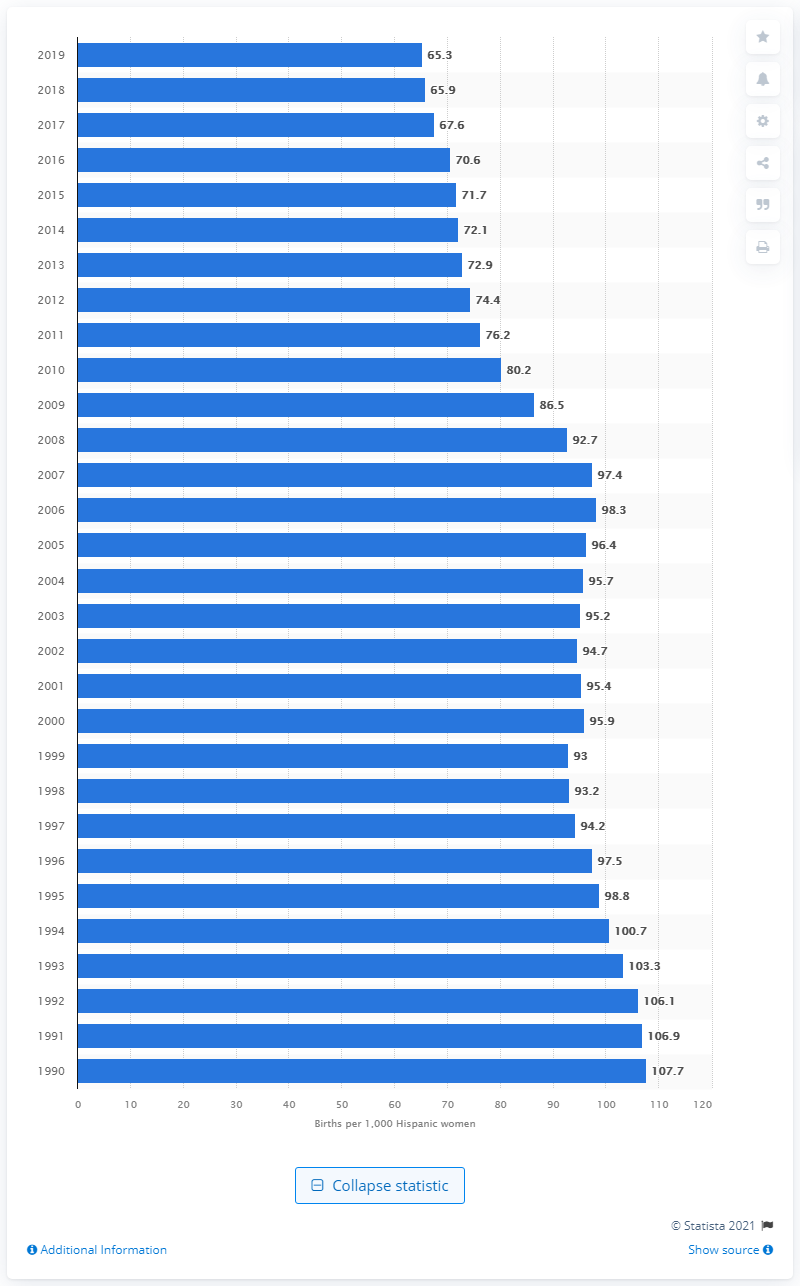Identify some key points in this picture. According to data from 2019, the fertility rate among Hispanics in the United States is 65.3. 